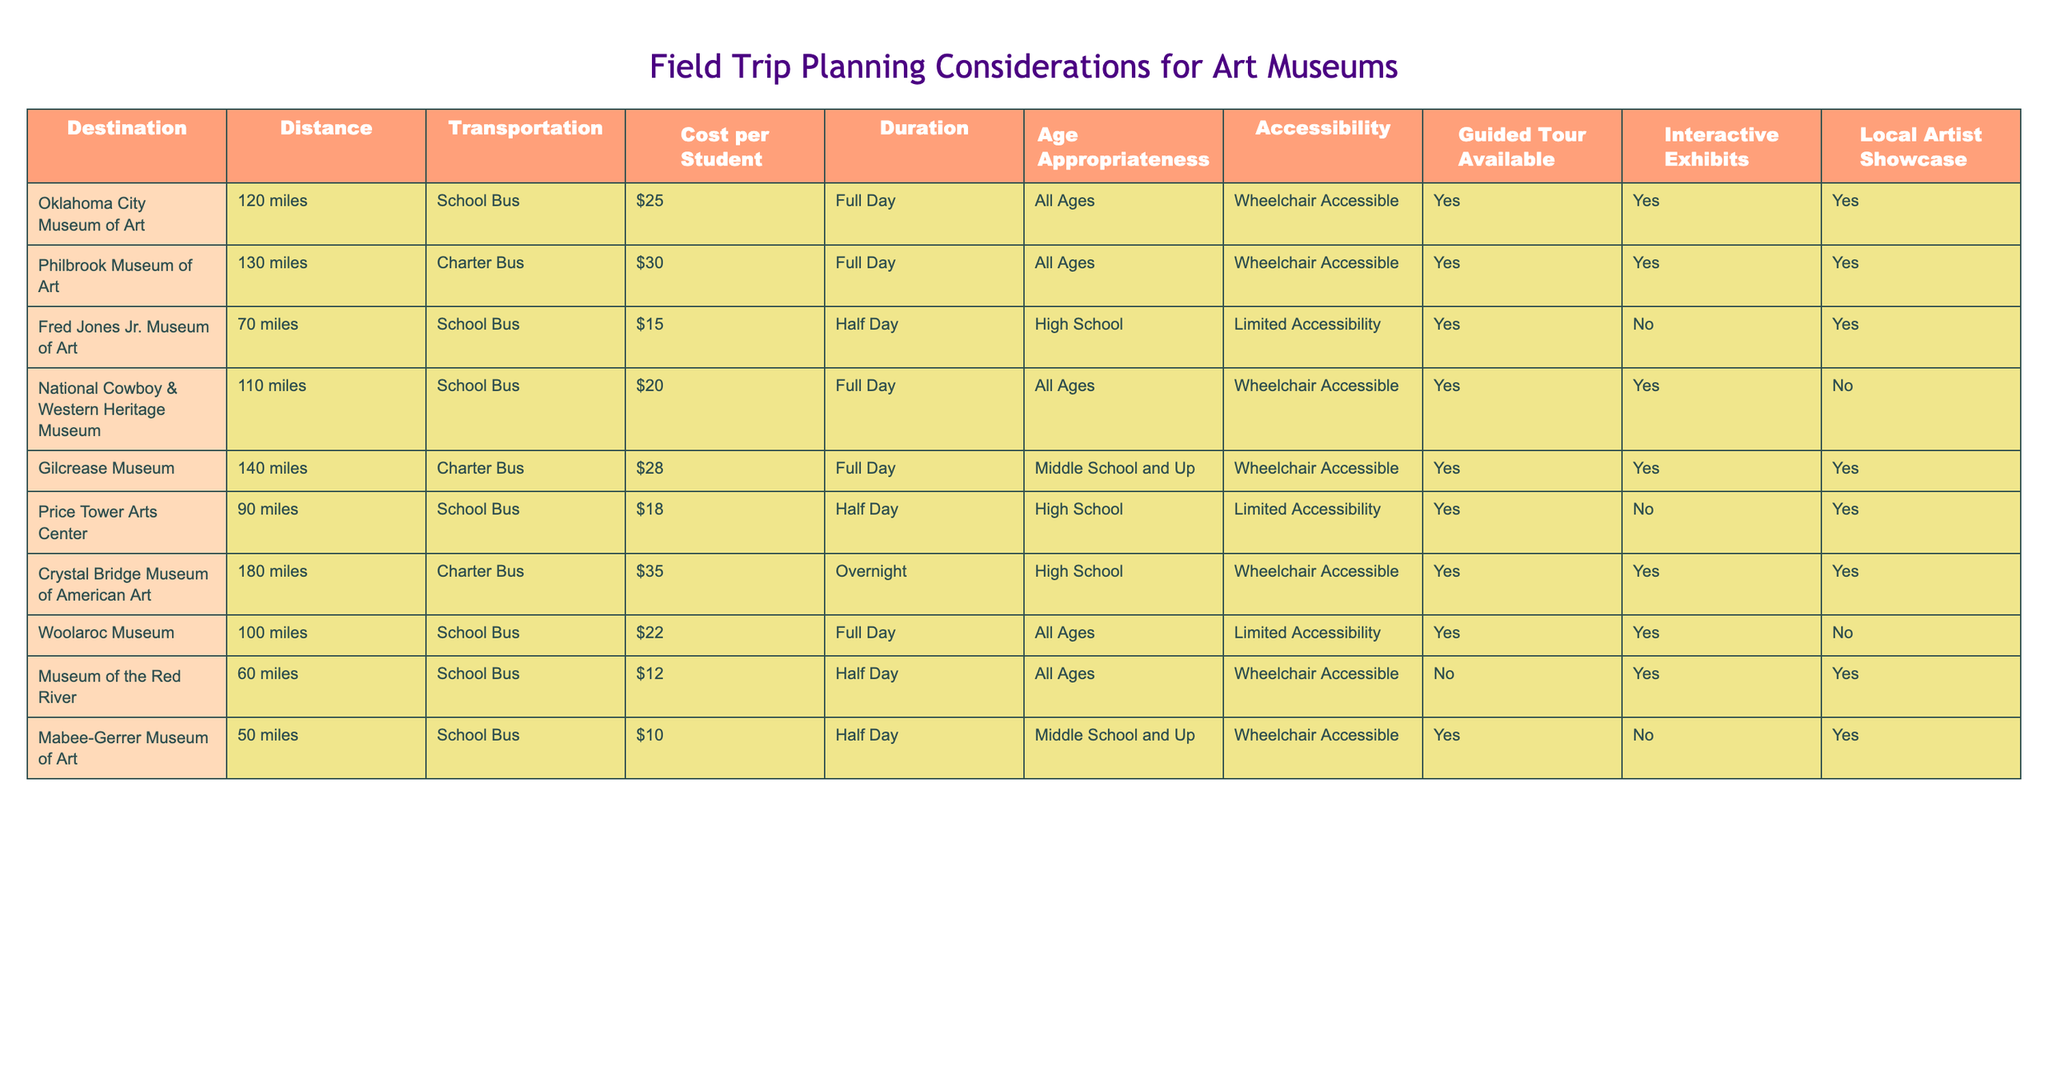What is the distance to the Oklahoma City Museum of Art? According to the table, the distance to the Oklahoma City Museum of Art is listed as 120 miles.
Answer: 120 miles Which museum has the lowest cost per student? The museum with the lowest cost per student is the Mabee-Gerrer Museum of Art, which costs $10 per student.
Answer: $10 Do all museums offer guided tours? No, not all museums offer guided tours. The Museum of the Red River does not have a guided tour available.
Answer: No Which museum is suitable for all ages and has interactive exhibits? The Oklahoma City Museum of Art is suitable for all ages and has interactive exhibits.
Answer: Oklahoma City Museum of Art What is the average cost per student for Half Day museums? The Half Day museums listed are Fred Jones Jr. Museum of Art ($15), Price Tower Arts Center ($18), Museum of the Red River ($12), and Mabee-Gerrer Museum of Art ($10). The total cost is $15 + $18 + $12 + $10 = $55, and there are 4 museums, so the average is $55 / 4 = $13.75.
Answer: $13.75 Are there any museums that do not have limited accessibility? Yes, multiple museums do not have limited accessibility. Both the Mabee-Gerrer Museum of Art and the Oklahoma City Museum of Art are marked as wheelchair accessible.
Answer: Yes What is the total distance covered if we visited all museums on a Half Day trip? The total distance for Half Day museums can be calculated by adding the distances of Fred Jones Jr. Museum of Art (70 miles), Price Tower Arts Center (90 miles), Museum of the Red River (60 miles), and Mabee-Gerrer Museum of Art (50 miles). The total is 70 + 90 + 60 + 50 = 270 miles.
Answer: 270 miles Which museum offers both a guided tour and a local artist showcase? The museums that offer both a guided tour and a local artist showcase are the Oklahoma City Museum of Art, Philbrook Museum of Art, and Woolaroc Museum.
Answer: Oklahoma City Museum of Art, Philbrook Museum of Art, Woolaroc Museum What is the maximum transportation cost among the museums? The transportation costs are $25, $30, $15, $20, $28, $18, $35, $22, and $10. The maximum transportation cost is $35 for the Crystal Bridge Museum of American Art.
Answer: $35 Does the Gilcrease Museum have an interactive exhibit? Yes, the Gilcrease Museum does offer interactive exhibits as indicated in the table.
Answer: Yes 